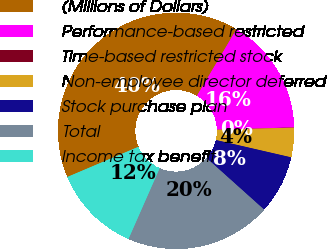Convert chart. <chart><loc_0><loc_0><loc_500><loc_500><pie_chart><fcel>(Millions of Dollars)<fcel>Performance-based restricted<fcel>Time-based restricted stock<fcel>Non-employee director deferred<fcel>Stock purchase plan<fcel>Total<fcel>Income tax benefit<nl><fcel>39.93%<fcel>16.0%<fcel>0.04%<fcel>4.03%<fcel>8.02%<fcel>19.98%<fcel>12.01%<nl></chart> 